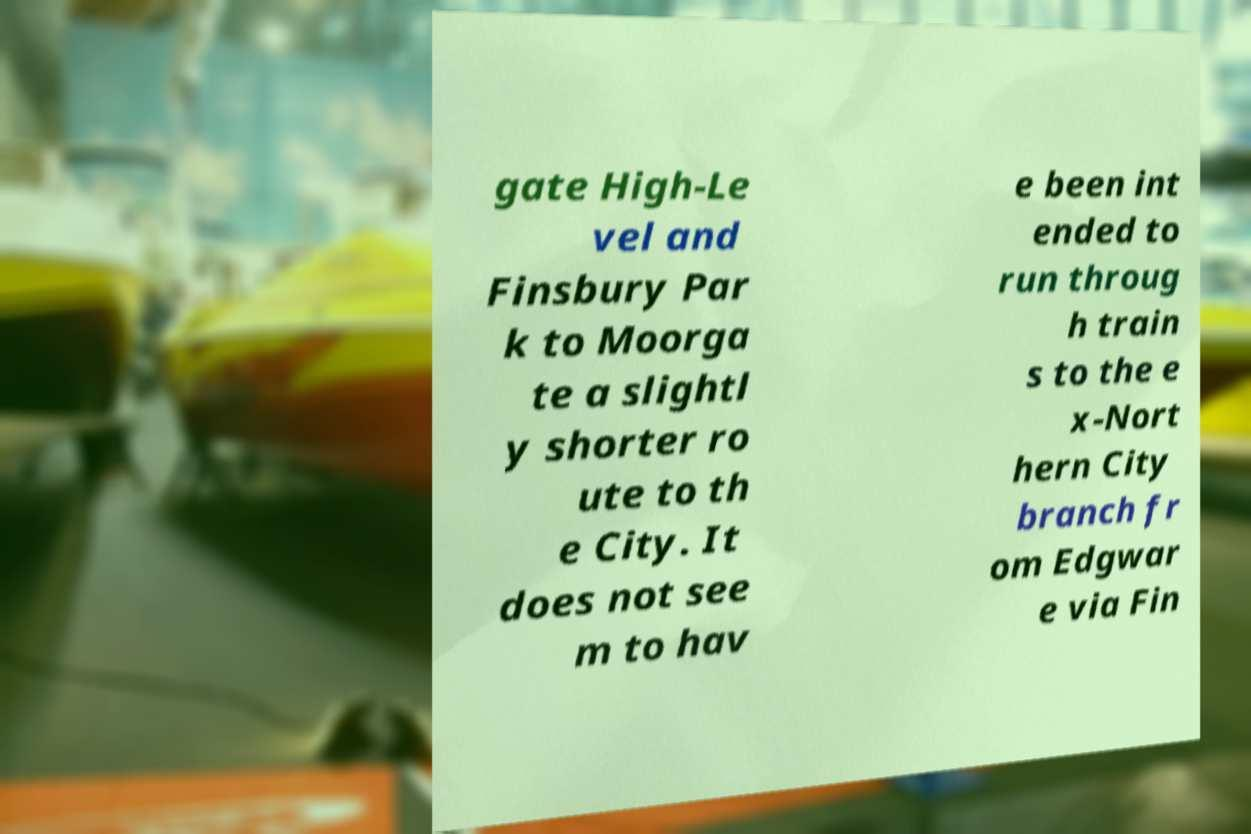Please identify and transcribe the text found in this image. gate High-Le vel and Finsbury Par k to Moorga te a slightl y shorter ro ute to th e City. It does not see m to hav e been int ended to run throug h train s to the e x-Nort hern City branch fr om Edgwar e via Fin 